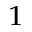<formula> <loc_0><loc_0><loc_500><loc_500>^ { 1 }</formula> 